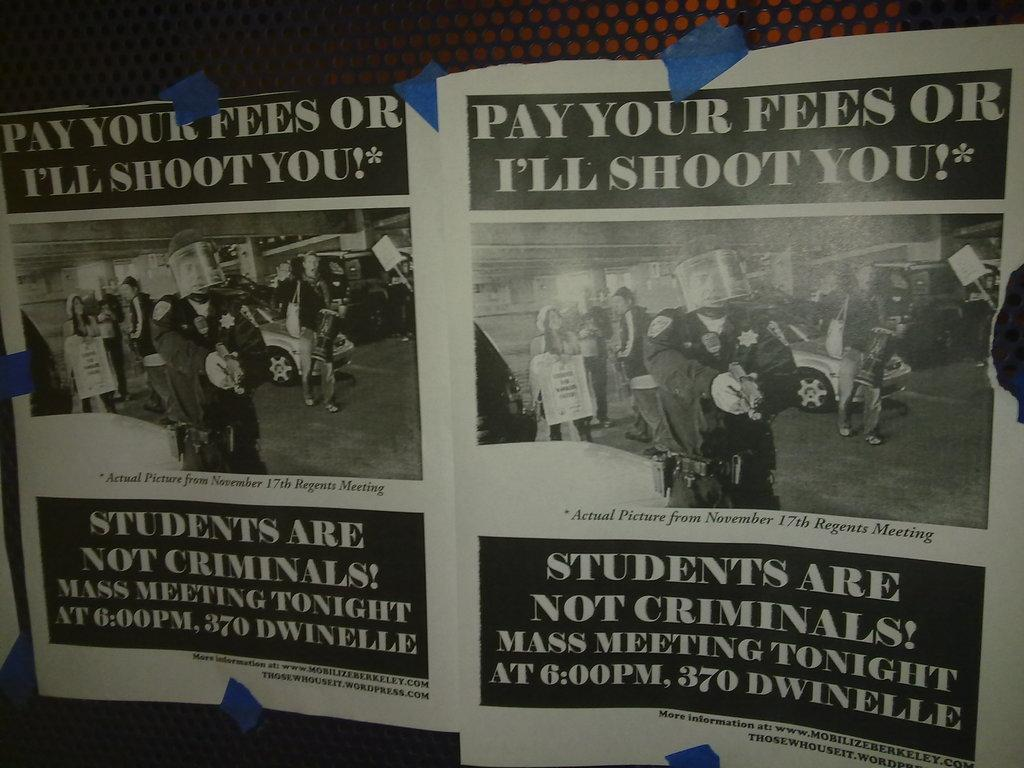<image>
Provide a brief description of the given image. A pair of flyers announce a mass meeting taking place tonight. 